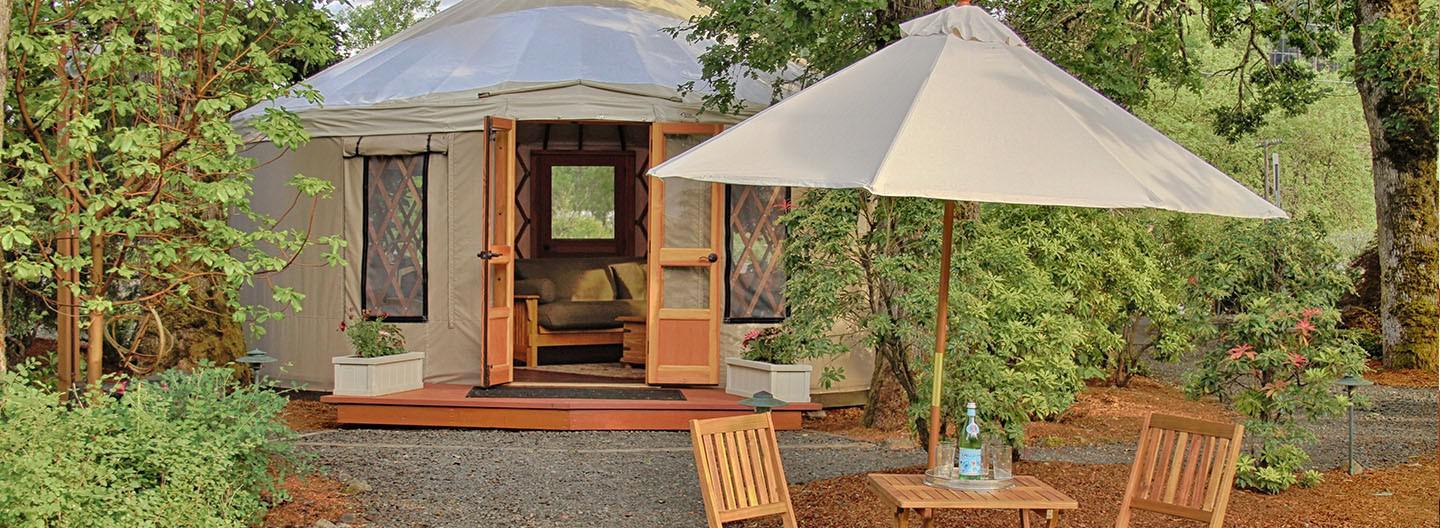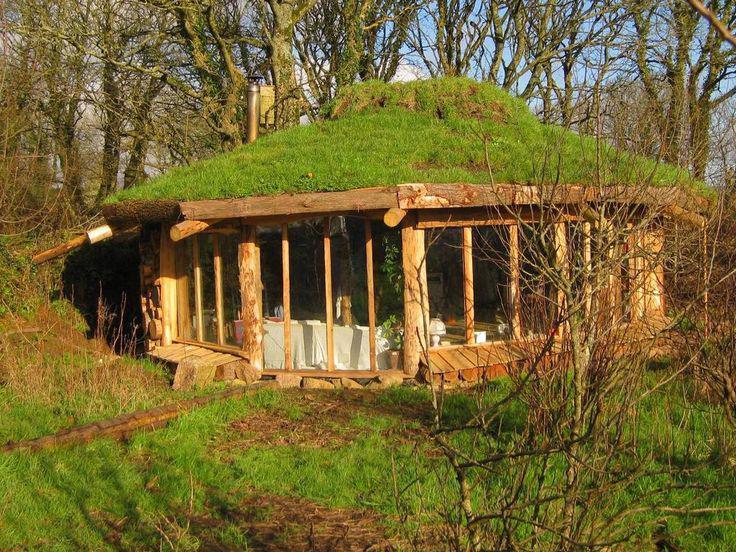The first image is the image on the left, the second image is the image on the right. Examine the images to the left and right. Is the description "There is at least one round window in the door in one of the images." accurate? Answer yes or no. No. 